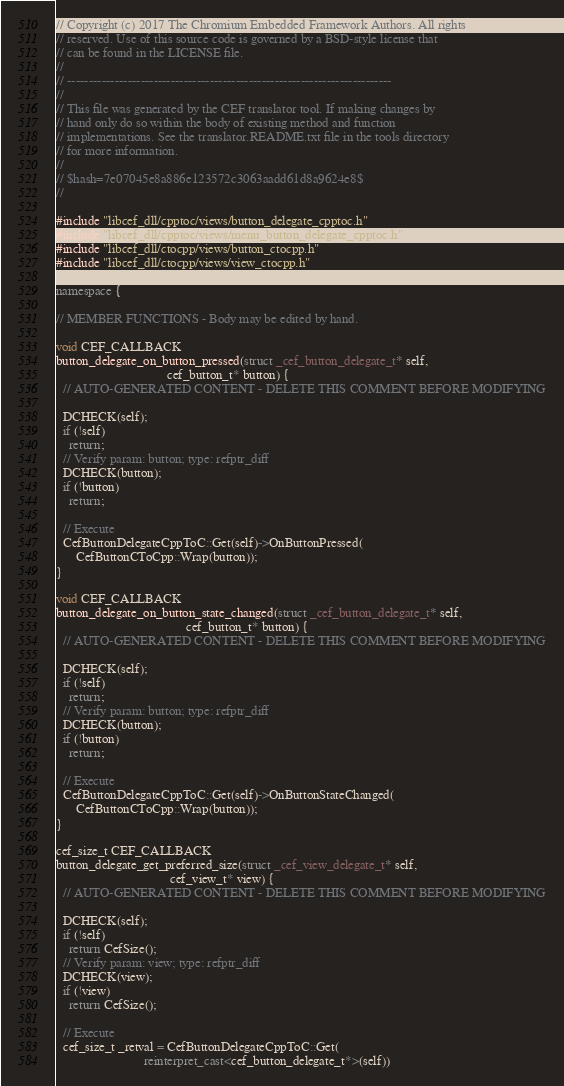<code> <loc_0><loc_0><loc_500><loc_500><_C++_>// Copyright (c) 2017 The Chromium Embedded Framework Authors. All rights
// reserved. Use of this source code is governed by a BSD-style license that
// can be found in the LICENSE file.
//
// ---------------------------------------------------------------------------
//
// This file was generated by the CEF translator tool. If making changes by
// hand only do so within the body of existing method and function
// implementations. See the translator.README.txt file in the tools directory
// for more information.
//
// $hash=7e07045e8a886e123572c3063aadd61d8a9624e8$
//

#include "libcef_dll/cpptoc/views/button_delegate_cpptoc.h"
#include "libcef_dll/cpptoc/views/menu_button_delegate_cpptoc.h"
#include "libcef_dll/ctocpp/views/button_ctocpp.h"
#include "libcef_dll/ctocpp/views/view_ctocpp.h"

namespace {

// MEMBER FUNCTIONS - Body may be edited by hand.

void CEF_CALLBACK
button_delegate_on_button_pressed(struct _cef_button_delegate_t* self,
                                  cef_button_t* button) {
  // AUTO-GENERATED CONTENT - DELETE THIS COMMENT BEFORE MODIFYING

  DCHECK(self);
  if (!self)
    return;
  // Verify param: button; type: refptr_diff
  DCHECK(button);
  if (!button)
    return;

  // Execute
  CefButtonDelegateCppToC::Get(self)->OnButtonPressed(
      CefButtonCToCpp::Wrap(button));
}

void CEF_CALLBACK
button_delegate_on_button_state_changed(struct _cef_button_delegate_t* self,
                                        cef_button_t* button) {
  // AUTO-GENERATED CONTENT - DELETE THIS COMMENT BEFORE MODIFYING

  DCHECK(self);
  if (!self)
    return;
  // Verify param: button; type: refptr_diff
  DCHECK(button);
  if (!button)
    return;

  // Execute
  CefButtonDelegateCppToC::Get(self)->OnButtonStateChanged(
      CefButtonCToCpp::Wrap(button));
}

cef_size_t CEF_CALLBACK
button_delegate_get_preferred_size(struct _cef_view_delegate_t* self,
                                   cef_view_t* view) {
  // AUTO-GENERATED CONTENT - DELETE THIS COMMENT BEFORE MODIFYING

  DCHECK(self);
  if (!self)
    return CefSize();
  // Verify param: view; type: refptr_diff
  DCHECK(view);
  if (!view)
    return CefSize();

  // Execute
  cef_size_t _retval = CefButtonDelegateCppToC::Get(
                           reinterpret_cast<cef_button_delegate_t*>(self))</code> 